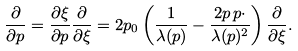Convert formula to latex. <formula><loc_0><loc_0><loc_500><loc_500>\frac { \partial } { \partial p } = \frac { \partial \xi } { \partial p } \frac { \partial } { \partial \xi } = 2 p _ { 0 } \left ( \frac { 1 } { \lambda ( p ) } - \frac { 2 p \, p \cdot } { \lambda ( p ) ^ { 2 } } \right ) \frac { \partial } { \partial \xi } .</formula> 